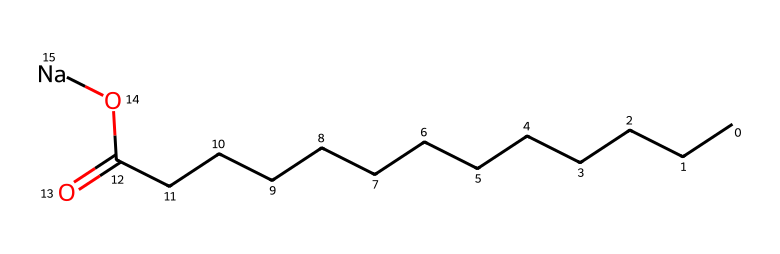What is the functional group present in this compound? The compound has a carboxylic acid functional group indicated by the presence of the -COOH feature (the carbon atom double-bonded to an oxygen atom and single-bonded to a hydroxyl group). In the chemical structure, it also includes a sodium ion, which suggests it's a salt.
Answer: carboxylate How many carbon atoms are in the longest chain of this structure? By examining the structure, we identify the longest continuous chain of carbon atoms that forms the backbone, which consists of 13 carbon atoms based on the 'C' symbols in the SMILES representation.
Answer: thirteen What type of agent is this compound primarily classified as? Considering the overall structure and presence of both hydrophilic (the carboxylate ion) and hydrophobic (the long hydrocarbon chain) parts, this compound can be classified as a surfactant.
Answer: surfactant What element indicates that this soap is biodegradable? The presence of a carbon-based backbone and a carboxylate functional group suggests that this compound is from a natural source, leading to its biodegradability, as organic compounds generally biodegrade efficiently in the environment.
Answer: carbon What is the role of sodium in this chemical structure? The sodium ion acts as a counterion to the carboxylate functional group, improving the solubility of the compound in water, which enhances its effectiveness as an eco-friendly cleaning agent.
Answer: counterion 